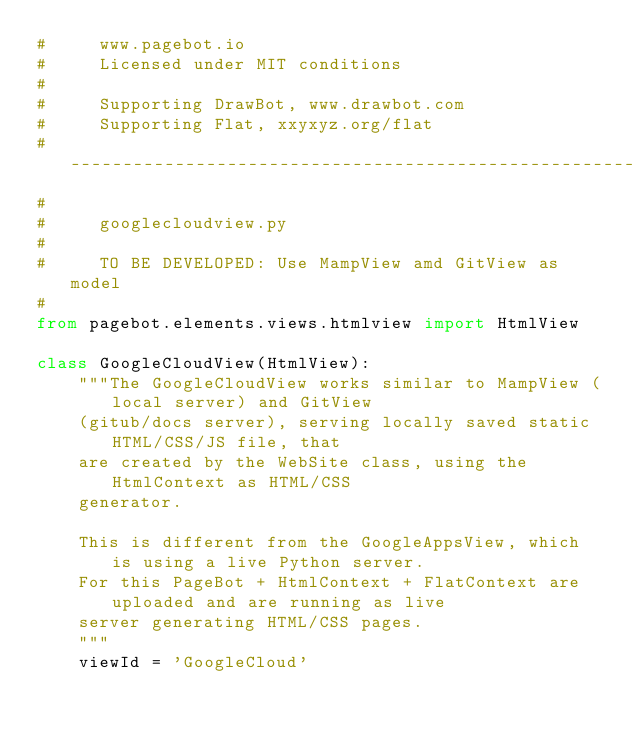<code> <loc_0><loc_0><loc_500><loc_500><_Python_>#     www.pagebot.io
#     Licensed under MIT conditions
#
#     Supporting DrawBot, www.drawbot.com
#     Supporting Flat, xxyxyz.org/flat
# -----------------------------------------------------------------------------
#
#     googlecloudview.py
#
#     TO BE DEVELOPED: Use MampView amd GitView as model
#
from pagebot.elements.views.htmlview import HtmlView

class GoogleCloudView(HtmlView):
    """The GoogleCloudView works similar to MampView (local server) and GitView
    (gitub/docs server), serving locally saved static HTML/CSS/JS file, that
    are created by the WebSite class, using the HtmlContext as HTML/CSS
    generator.

    This is different from the GoogleAppsView, which is using a live Python server.
    For this PageBot + HtmlContext + FlatContext are uploaded and are running as live
    server generating HTML/CSS pages.
    """
    viewId = 'GoogleCloud'
</code> 